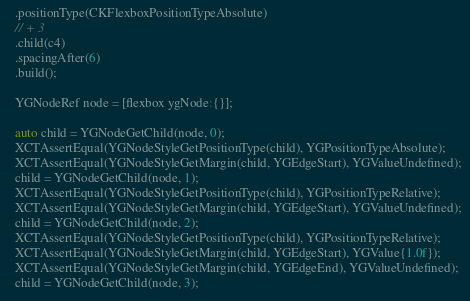Convert code to text. <code><loc_0><loc_0><loc_500><loc_500><_ObjectiveC_>  .positionType(CKFlexboxPositionTypeAbsolute)
  // + 3
  .child(c4)
  .spacingAfter(6)
  .build();

  YGNodeRef node = [flexbox ygNode:{}];

  auto child = YGNodeGetChild(node, 0);
  XCTAssertEqual(YGNodeStyleGetPositionType(child), YGPositionTypeAbsolute);
  XCTAssertEqual(YGNodeStyleGetMargin(child, YGEdgeStart), YGValueUndefined);
  child = YGNodeGetChild(node, 1);
  XCTAssertEqual(YGNodeStyleGetPositionType(child), YGPositionTypeRelative);
  XCTAssertEqual(YGNodeStyleGetMargin(child, YGEdgeStart), YGValueUndefined);
  child = YGNodeGetChild(node, 2);
  XCTAssertEqual(YGNodeStyleGetPositionType(child), YGPositionTypeRelative);
  XCTAssertEqual(YGNodeStyleGetMargin(child, YGEdgeStart), YGValue{1.0f});
  XCTAssertEqual(YGNodeStyleGetMargin(child, YGEdgeEnd), YGValueUndefined);
  child = YGNodeGetChild(node, 3);</code> 